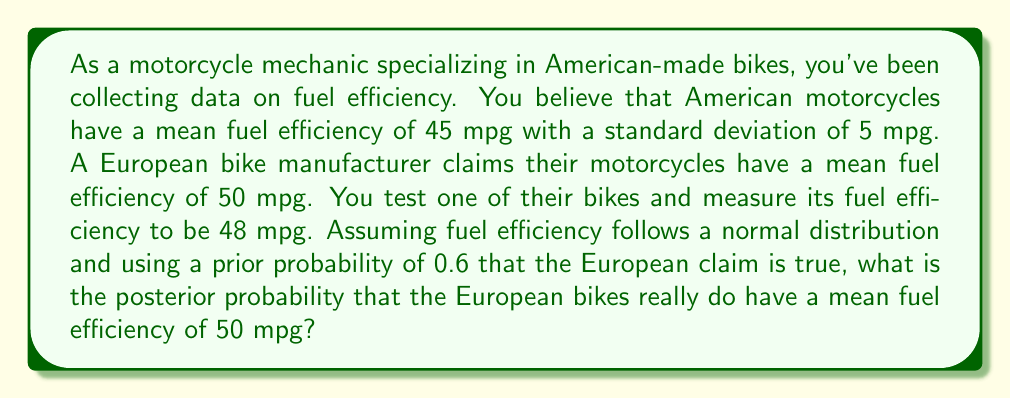Show me your answer to this math problem. To solve this problem, we'll use Bayesian inference. Let's break it down step by step:

1) Define our hypotheses:
   $H_0$: European bikes have a mean fuel efficiency of 50 mpg
   $H_1$: European bikes do not have a mean fuel efficiency of 50 mpg

2) Given:
   - Prior probability $P(H_0) = 0.6$
   - Prior probability $P(H_1) = 1 - 0.6 = 0.4$
   - American bikes: $\mu_A = 45$ mpg, $\sigma_A = 5$ mpg
   - Observed European bike efficiency: $x = 48$ mpg

3) Calculate the likelihood of observing 48 mpg if $H_0$ is true:
   Assuming the same standard deviation as American bikes:
   $$P(x|H_0) = \frac{1}{\sigma\sqrt{2\pi}} e^{-\frac{(x-\mu)^2}{2\sigma^2}}$$
   $$P(48|H_0) = \frac{1}{5\sqrt{2\pi}} e^{-\frac{(48-50)^2}{2(5^2)}} \approx 0.0780$$

4) Calculate the likelihood of observing 48 mpg if $H_1$ is true:
   We'll assume the mean under $H_1$ is the same as American bikes:
   $$P(48|H_1) = \frac{1}{5\sqrt{2\pi}} e^{-\frac{(48-45)^2}{2(5^2)}} \approx 0.0647$$

5) Apply Bayes' theorem:
   $$P(H_0|x) = \frac{P(x|H_0)P(H_0)}{P(x|H_0)P(H_0) + P(x|H_1)P(H_1)}$$

   $$P(H_0|48) = \frac{0.0780 \times 0.6}{0.0780 \times 0.6 + 0.0647 \times 0.4} \approx 0.6441$$

Therefore, the posterior probability that the European bikes have a mean fuel efficiency of 50 mpg, given the observed data, is approximately 0.6441 or 64.41%.
Answer: 0.6441 (or 64.41%) 